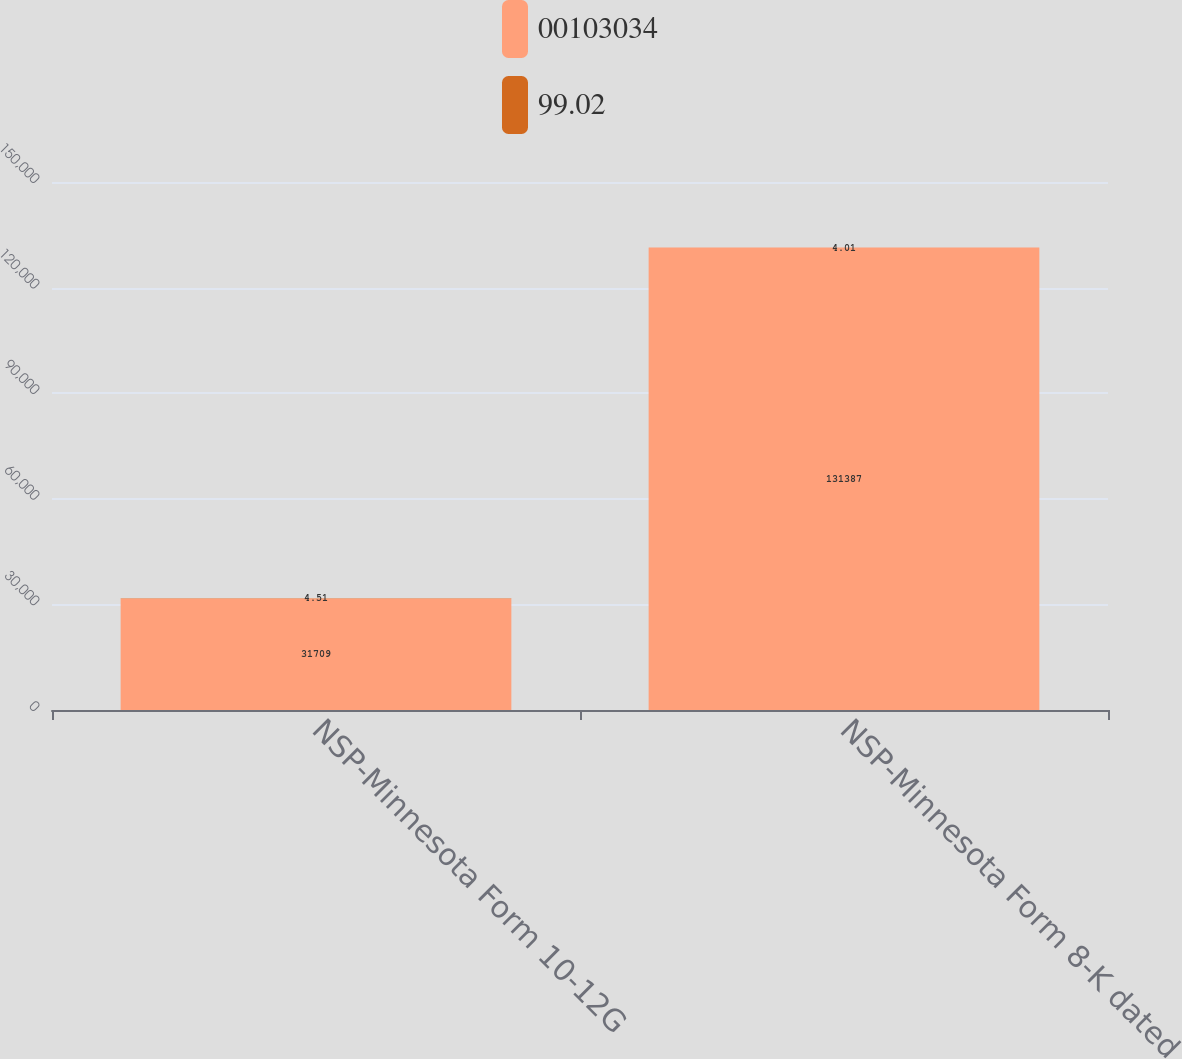Convert chart. <chart><loc_0><loc_0><loc_500><loc_500><stacked_bar_chart><ecel><fcel>NSP-Minnesota Form 10-12G<fcel>NSP-Minnesota Form 8-K dated<nl><fcel>103034<fcel>31709<fcel>131387<nl><fcel>99.02<fcel>4.51<fcel>4.01<nl></chart> 